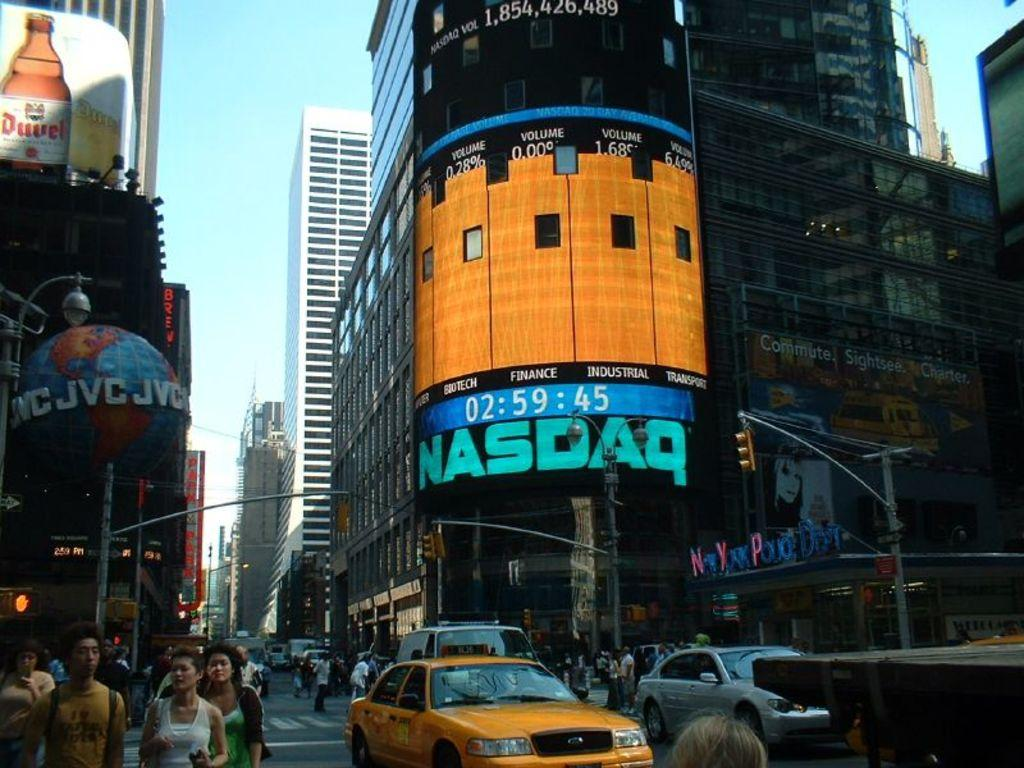<image>
Render a clear and concise summary of the photo. A busy intersection with a large monitor listing the NASDAQ stock ratings. 